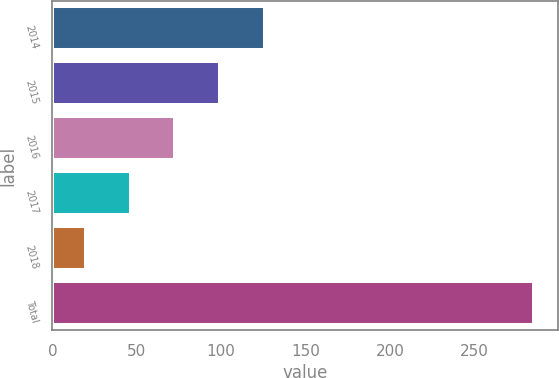<chart> <loc_0><loc_0><loc_500><loc_500><bar_chart><fcel>2014<fcel>2015<fcel>2016<fcel>2017<fcel>2018<fcel>Total<nl><fcel>126.02<fcel>99.44<fcel>72.86<fcel>46.28<fcel>19.7<fcel>285.5<nl></chart> 